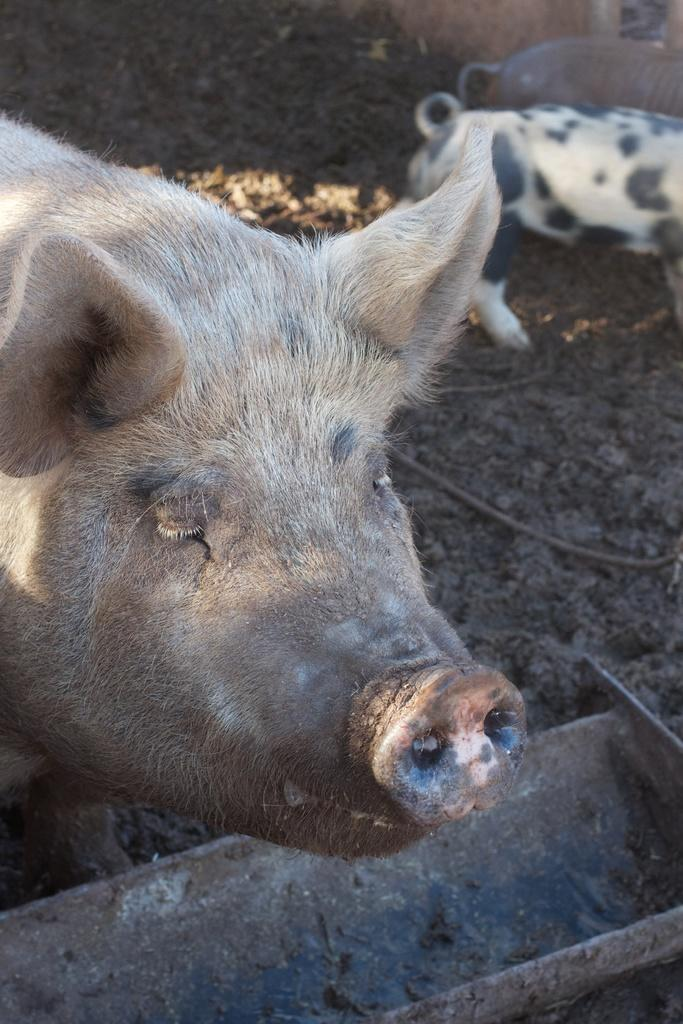What animals are present in the image? There are pigs in the image. Where are the pigs located? The pigs are on the ground. What type of flower can be seen growing near the pigs in the image? There is no flower present in the image; it only features pigs on the ground. 